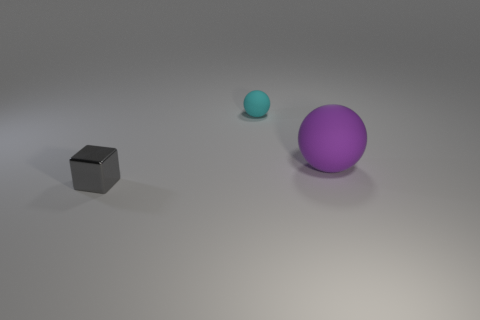How many objects are either tiny things that are in front of the cyan ball or large purple metallic objects? In the image, there is one large purple metallic ball and a smaller cyan ball in front of it. There are no tiny objects in front of the cyan ball other than the shadow it casts. Therefore, the total count of objects that are either tiny things in front of the cyan ball or large purple metallic objects is one, which is the large purple metallic ball. 